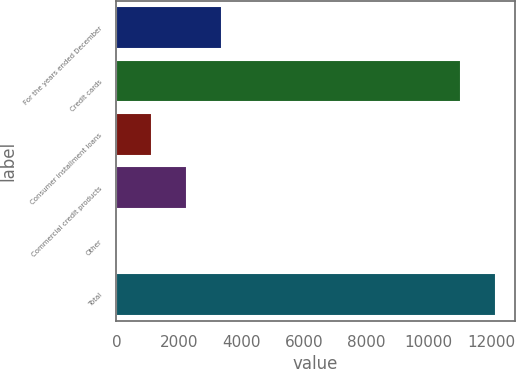<chart> <loc_0><loc_0><loc_500><loc_500><bar_chart><fcel>For the years ended December<fcel>Credit cards<fcel>Consumer installment loans<fcel>Commercial credit products<fcel>Other<fcel>Total<nl><fcel>3389.2<fcel>11015<fcel>1130.4<fcel>2259.8<fcel>1<fcel>12144.4<nl></chart> 